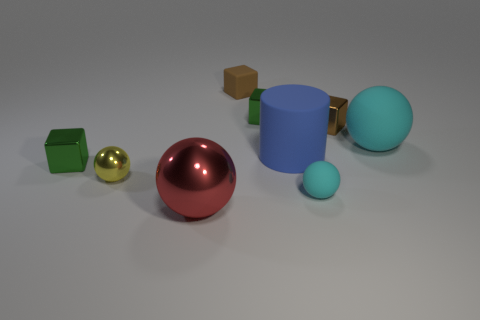Are there an equal number of small green blocks that are right of the tiny cyan thing and small brown matte balls?
Your response must be concise. Yes. How many things are either cyan matte objects behind the blue thing or small spheres?
Give a very brief answer. 3. There is a rubber object that is to the left of the large cyan ball and behind the blue thing; what shape is it?
Provide a short and direct response. Cube. How many objects are either green cubes right of the yellow metal thing or green cubes in front of the big blue cylinder?
Ensure brevity in your answer.  2. How many other things are the same size as the yellow sphere?
Give a very brief answer. 5. Does the matte sphere that is on the right side of the tiny brown metallic object have the same color as the large cylinder?
Keep it short and to the point. No. There is a metal object that is both behind the blue cylinder and on the left side of the big blue rubber thing; what is its size?
Your answer should be compact. Small. How many big objects are either blue rubber things or red balls?
Give a very brief answer. 2. There is a tiny shiny thing to the left of the tiny metal ball; what is its shape?
Keep it short and to the point. Cube. How many purple metallic cylinders are there?
Provide a succinct answer. 0. 